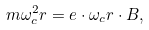Convert formula to latex. <formula><loc_0><loc_0><loc_500><loc_500>m \omega _ { c } ^ { 2 } r = e \cdot \omega _ { c } r \cdot B ,</formula> 